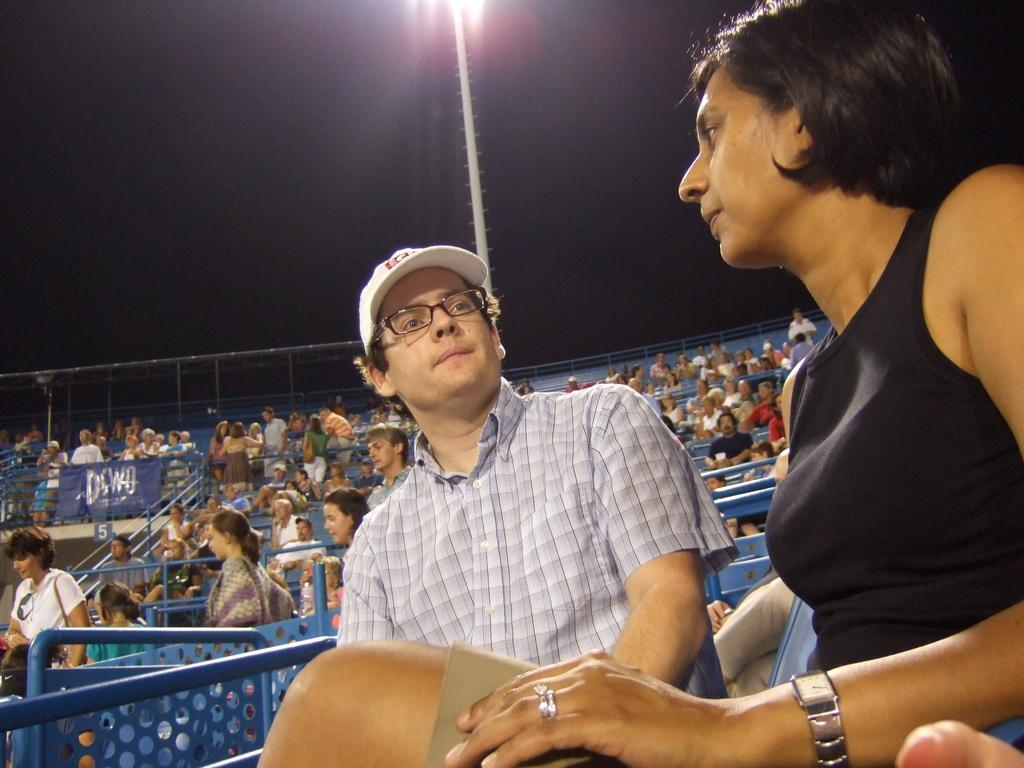How many people are in the image? There is a group of people in the image, but the exact number cannot be determined from the provided facts. What can be seen in the background of the image? There is a pole with lights in the background of the image. What is located on the left side of the image? There are metal rods on the left side of the image. What fictional company do the people in the image work for? There is no information about the people or their company in the image, and the provided facts do not mention any fictional elements. 